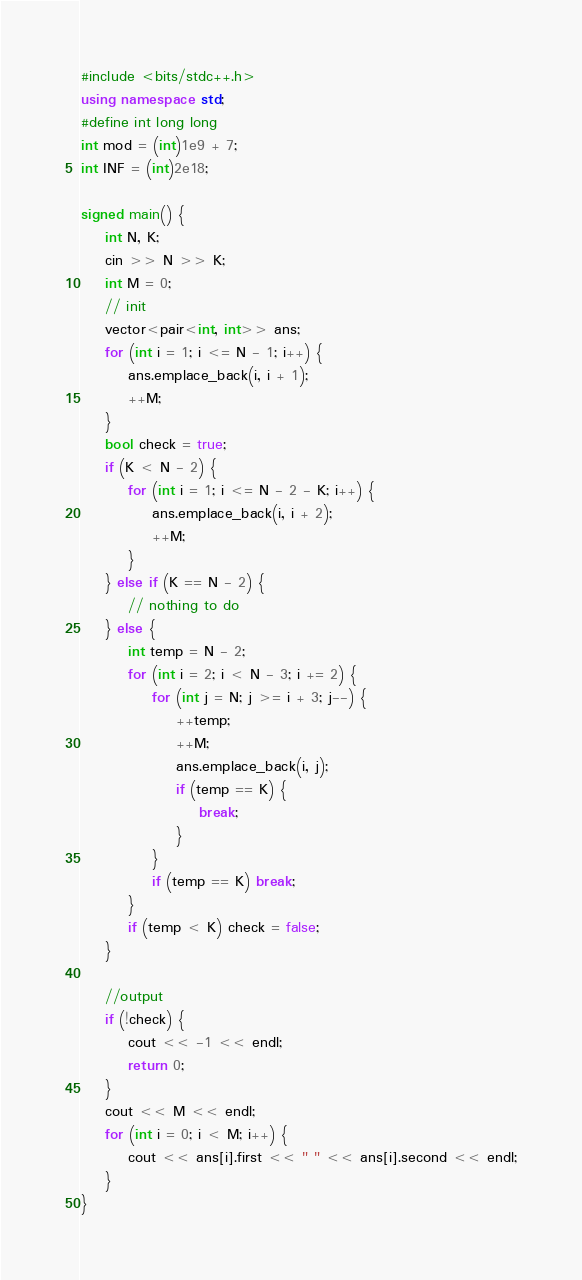<code> <loc_0><loc_0><loc_500><loc_500><_C++_>#include <bits/stdc++.h>
using namespace std;
#define int long long
int mod = (int)1e9 + 7;
int INF = (int)2e18;

signed main() {
    int N, K;
    cin >> N >> K;
    int M = 0;
    // init
    vector<pair<int, int>> ans;
    for (int i = 1; i <= N - 1; i++) {
        ans.emplace_back(i, i + 1);
        ++M;
    }
    bool check = true;
    if (K < N - 2) {
        for (int i = 1; i <= N - 2 - K; i++) {
            ans.emplace_back(i, i + 2);
            ++M;
        }
    } else if (K == N - 2) {
        // nothing to do
    } else {
        int temp = N - 2;
        for (int i = 2; i < N - 3; i += 2) {
            for (int j = N; j >= i + 3; j--) {
                ++temp;
                ++M;
                ans.emplace_back(i, j);
                if (temp == K) {
                    break;
                }
            }
            if (temp == K) break;
        }
        if (temp < K) check = false;
    }

    //output
    if (!check) {
        cout << -1 << endl;
        return 0;
    }
    cout << M << endl;
    for (int i = 0; i < M; i++) {
        cout << ans[i].first << " " << ans[i].second << endl;
    }
}
</code> 